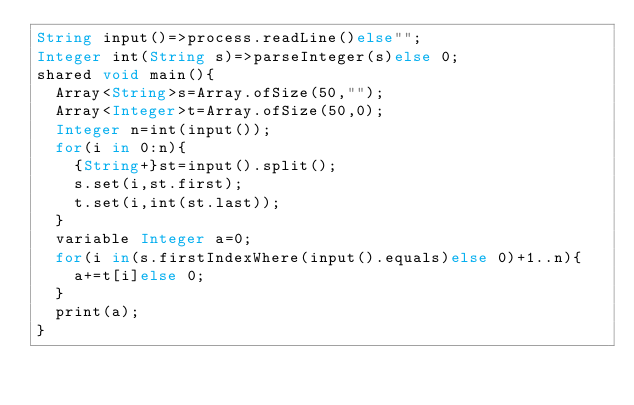Convert code to text. <code><loc_0><loc_0><loc_500><loc_500><_Ceylon_>String input()=>process.readLine()else""; 
Integer int(String s)=>parseInteger(s)else 0;
shared void main(){
  Array<String>s=Array.ofSize(50,"");
  Array<Integer>t=Array.ofSize(50,0);
  Integer n=int(input());
  for(i in 0:n){
    {String+}st=input().split();
    s.set(i,st.first);
    t.set(i,int(st.last));
  }
  variable Integer a=0;
  for(i in(s.firstIndexWhere(input().equals)else 0)+1..n){
    a+=t[i]else 0;
  }
  print(a);
}
</code> 